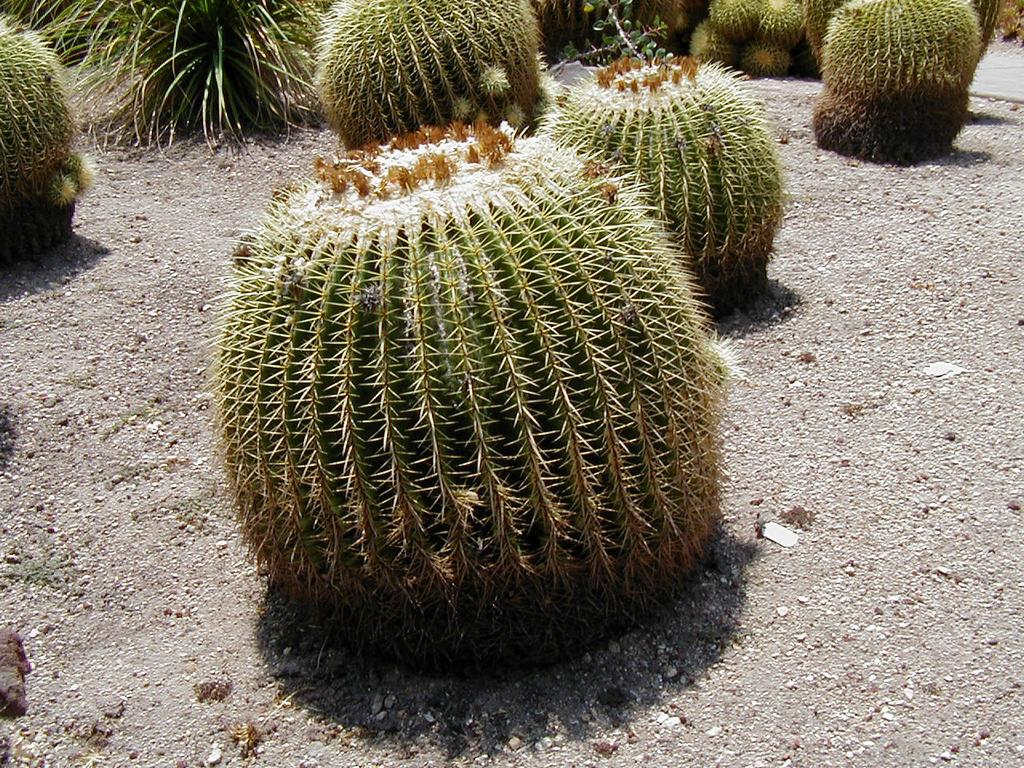What type of plants are in the image? There are cactus plants in the image. How does the earth beam energy to the cactus plants in the image? There is no mention of the earth or energy beams in the image; it simply features cactus plants. 